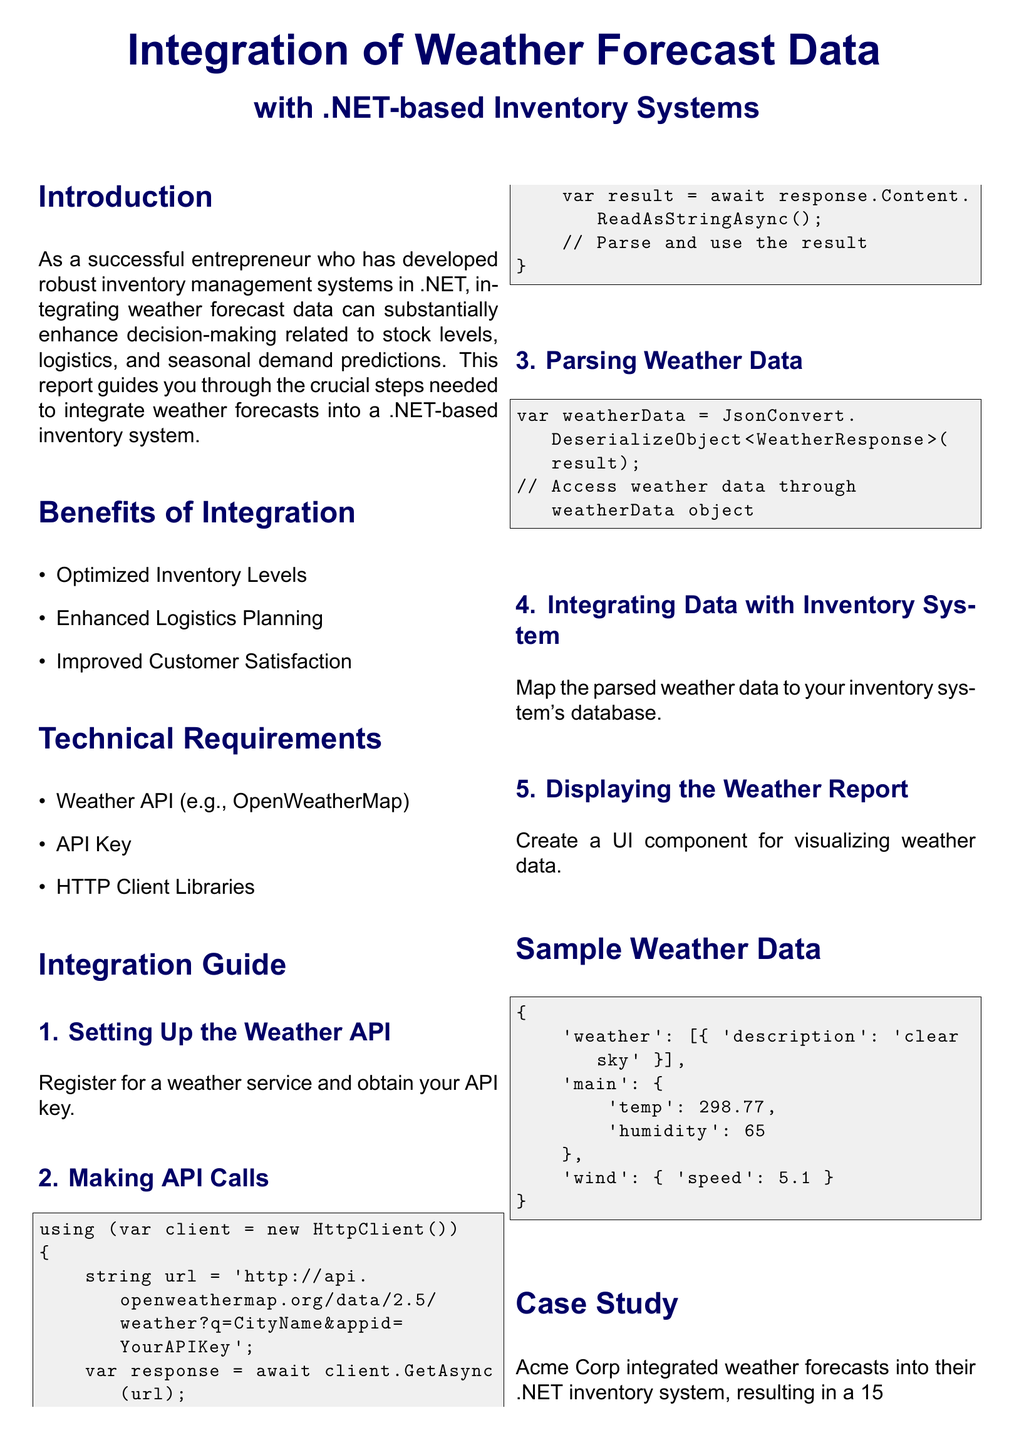What is the title of the report? The title of the report is prominently displayed at the beginning of the document.
Answer: Integration of Weather Forecast Data with .NET-based Inventory Systems What is one benefit of integrating weather data? The report lists several benefits of integration, including optimizing inventory levels.
Answer: Optimized Inventory Levels What API is suggested for weather data integration? The document specifies using a weather service API, specifically mentioning one example.
Answer: OpenWeatherMap What is the suggested HTTP client library in the integration guide? The integration guide mentions using libraries for making HTTP calls but does not specify a particular library name.
Answer: HTTP Client Libraries What improvement did Acme Corp experience in stock turnover? The case study presents quantifiable benefits that Acme Corp experienced after integration.
Answer: 15% How many steps are outlined in the Integration Guide? The document details the steps to take for integration, and each step is clearly numbered.
Answer: 5 What is the humidity level in the sample weather data? The sample weather data includes key metrics such as temperature and humidity levels.
Answer: 65 What is the conclusion about the integration of weather data? The conclusion summarizes the overall benefits of integrating weather forecast data within the inventory system context.
Answer: Optimize stock levels and improve logistics 